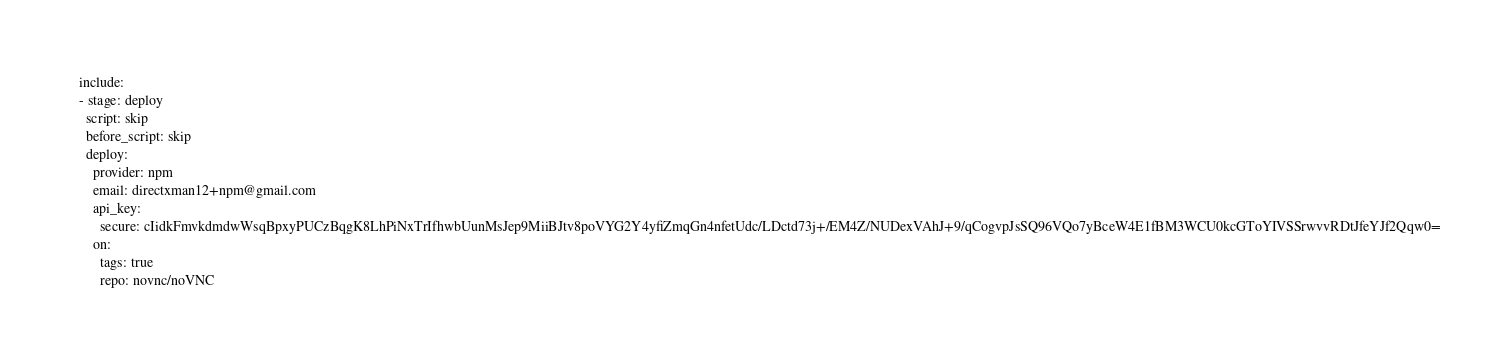Convert code to text. <code><loc_0><loc_0><loc_500><loc_500><_YAML_>  include:
  - stage: deploy
    script: skip
    before_script: skip
    deploy:
      provider: npm
      email: directxman12+npm@gmail.com
      api_key:
        secure: cIidkFmvkdmdwWsqBpxyPUCzBqgK8LhPiNxTrIfhwbUunMsJep9MiiBJtv8poVYG2Y4yfiZmqGn4nfetUdc/LDctd73j+/EM4Z/NUDexVAhJ+9/qCogvpJsSQ96VQo7yBceW4E1fBM3WCU0kcGToYIVSSrwvvRDtJfeYJf2Qqw0=
      on:
        tags: true
        repo: novnc/noVNC


</code> 